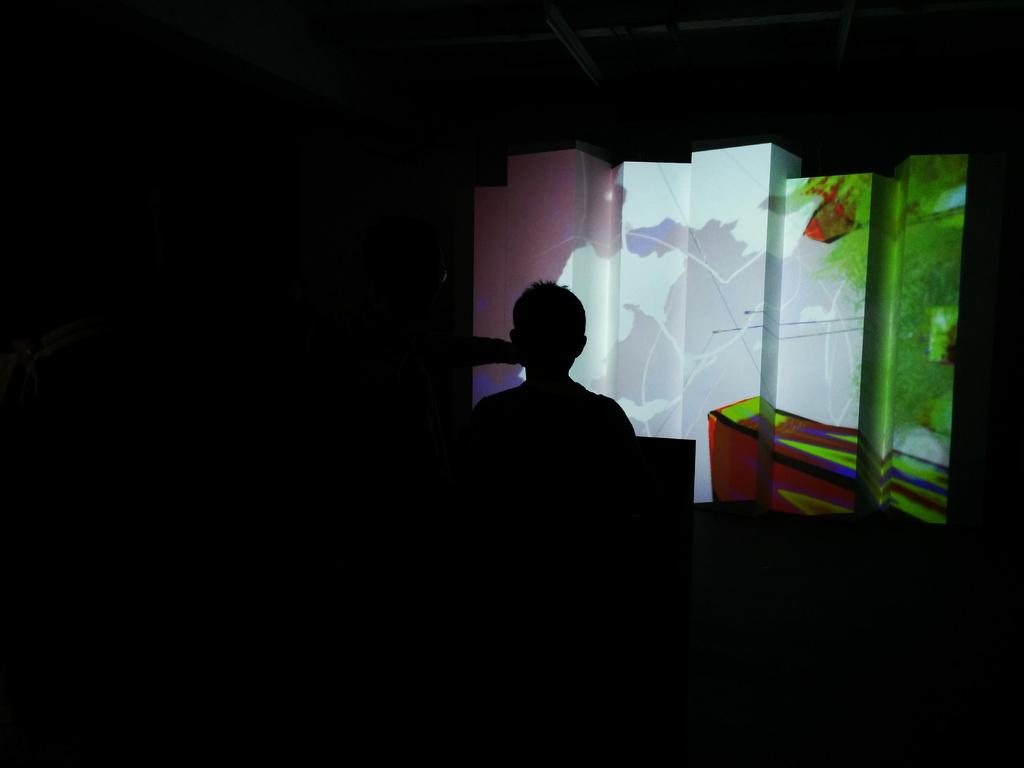Who or what is the main subject of the image? There is a person in the image. What can be seen in the background of the image? There is a painting in the background of the image. What colors are present in the painting? The painting has green, white, and pink colors. What type of education does the person in the image have? There is no information about the person's education in the image. Is the person in the image currently in a hospital? There is no indication of a hospital or any medical context in the image. 